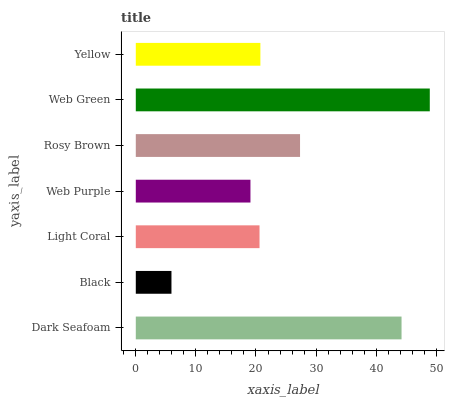Is Black the minimum?
Answer yes or no. Yes. Is Web Green the maximum?
Answer yes or no. Yes. Is Light Coral the minimum?
Answer yes or no. No. Is Light Coral the maximum?
Answer yes or no. No. Is Light Coral greater than Black?
Answer yes or no. Yes. Is Black less than Light Coral?
Answer yes or no. Yes. Is Black greater than Light Coral?
Answer yes or no. No. Is Light Coral less than Black?
Answer yes or no. No. Is Yellow the high median?
Answer yes or no. Yes. Is Yellow the low median?
Answer yes or no. Yes. Is Black the high median?
Answer yes or no. No. Is Light Coral the low median?
Answer yes or no. No. 